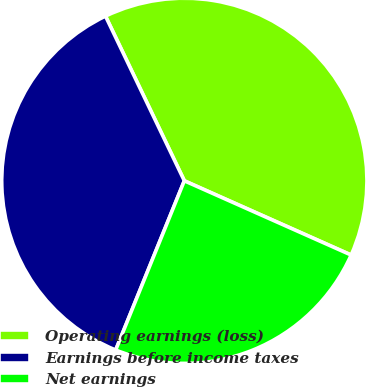Convert chart to OTSL. <chart><loc_0><loc_0><loc_500><loc_500><pie_chart><fcel>Operating earnings (loss)<fcel>Earnings before income taxes<fcel>Net earnings<nl><fcel>38.77%<fcel>36.76%<fcel>24.47%<nl></chart> 